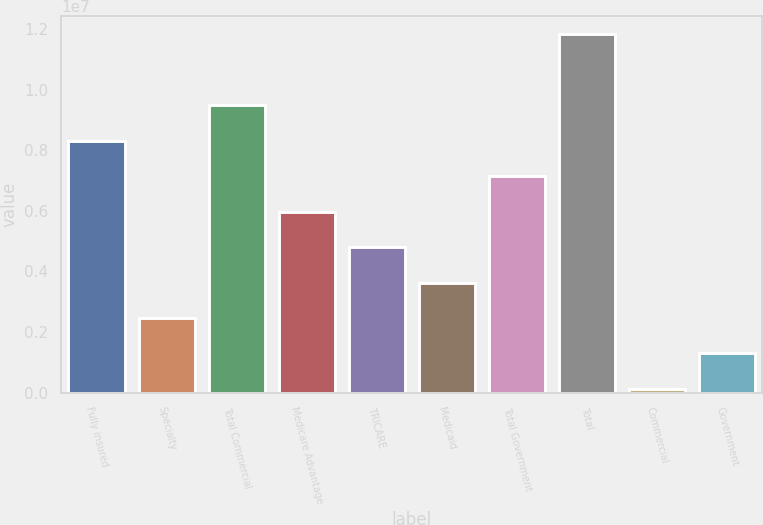Convert chart to OTSL. <chart><loc_0><loc_0><loc_500><loc_500><bar_chart><fcel>Fully insured<fcel>Specialty<fcel>Total Commercial<fcel>Medicare Advantage<fcel>TRICARE<fcel>Medicaid<fcel>Total Government<fcel>Total<fcel>Commercial<fcel>Government<nl><fcel>8.31455e+06<fcel>2.46333e+06<fcel>9.4848e+06<fcel>5.97406e+06<fcel>4.80382e+06<fcel>3.63358e+06<fcel>7.14431e+06<fcel>1.18253e+07<fcel>122846<fcel>1.29309e+06<nl></chart> 